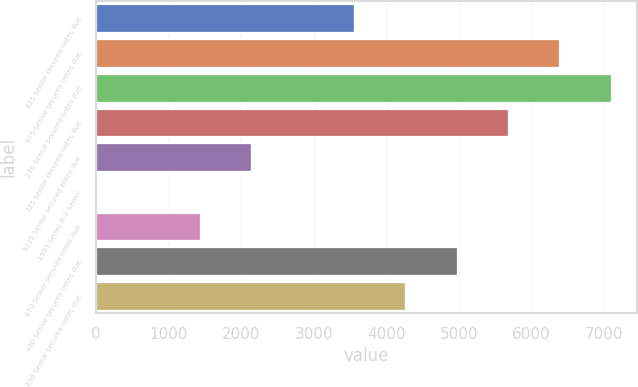Convert chart. <chart><loc_0><loc_0><loc_500><loc_500><bar_chart><fcel>625 Senior secured notes due<fcel>975 Senior secured notes due<fcel>270 Senior secured notes due<fcel>325 Senior secured notes due<fcel>6125 Senior secured notes due<fcel>1993 Series B-1 Senior<fcel>670 Senior secured notes due<fcel>480 Senior secured notes due<fcel>430 Senior secured notes due<nl><fcel>3555.5<fcel>6386.3<fcel>7094<fcel>5678.6<fcel>2140.1<fcel>17<fcel>1432.4<fcel>4970.9<fcel>4263.2<nl></chart> 